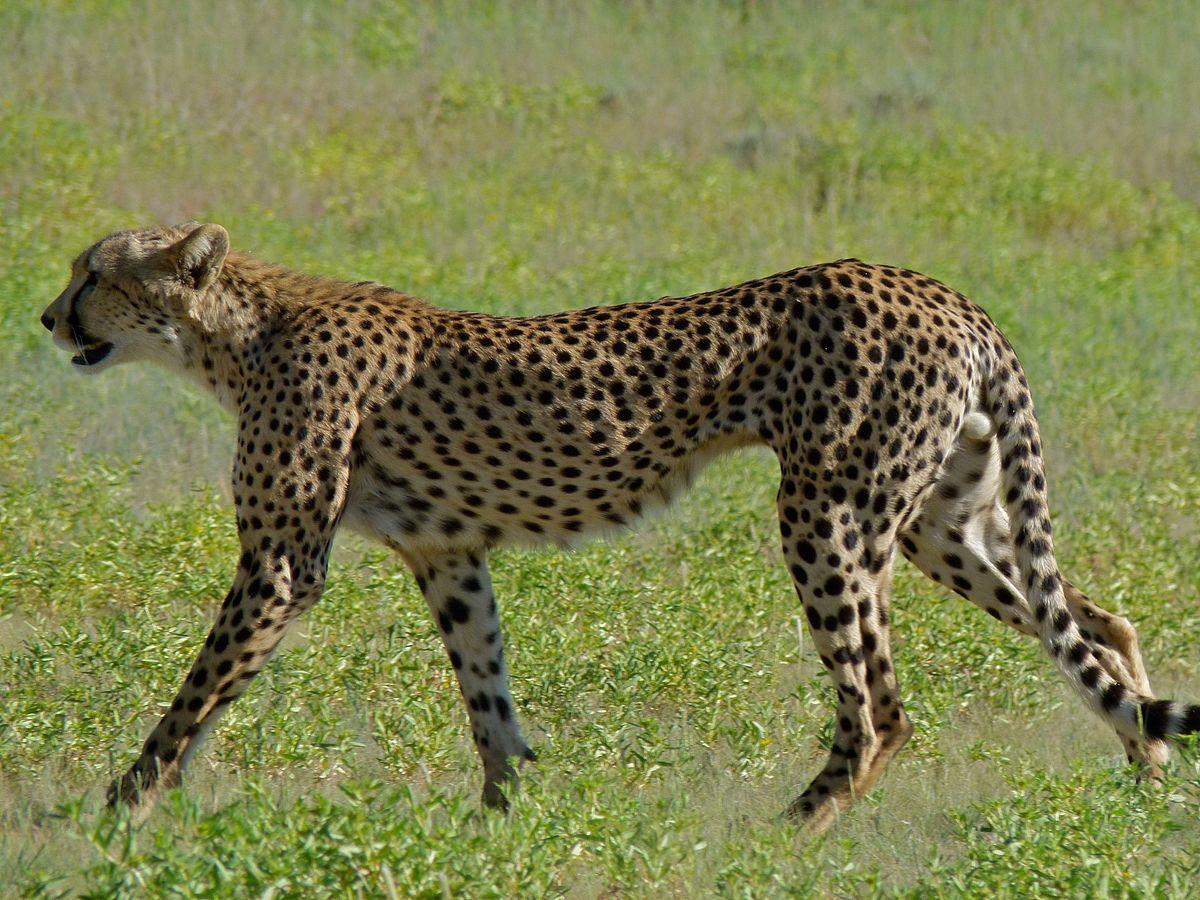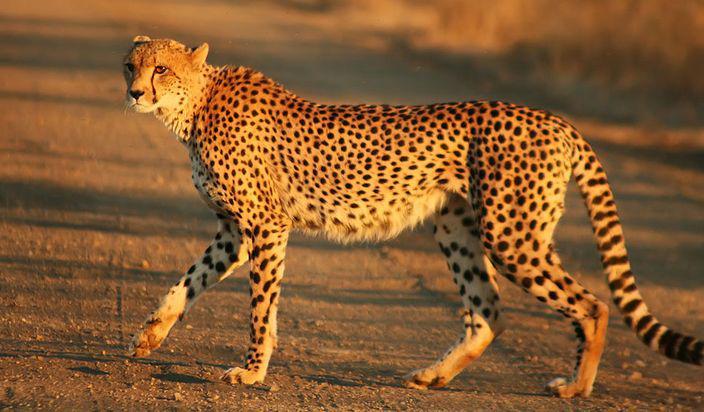The first image is the image on the left, the second image is the image on the right. Examine the images to the left and right. Is the description "An image shows a spotted wild cat jumping a horned animal from behind." accurate? Answer yes or no. No. The first image is the image on the left, the second image is the image on the right. Assess this claim about the two images: "A cheetah is grabbing its prey from behind in the left image.". Correct or not? Answer yes or no. No. 